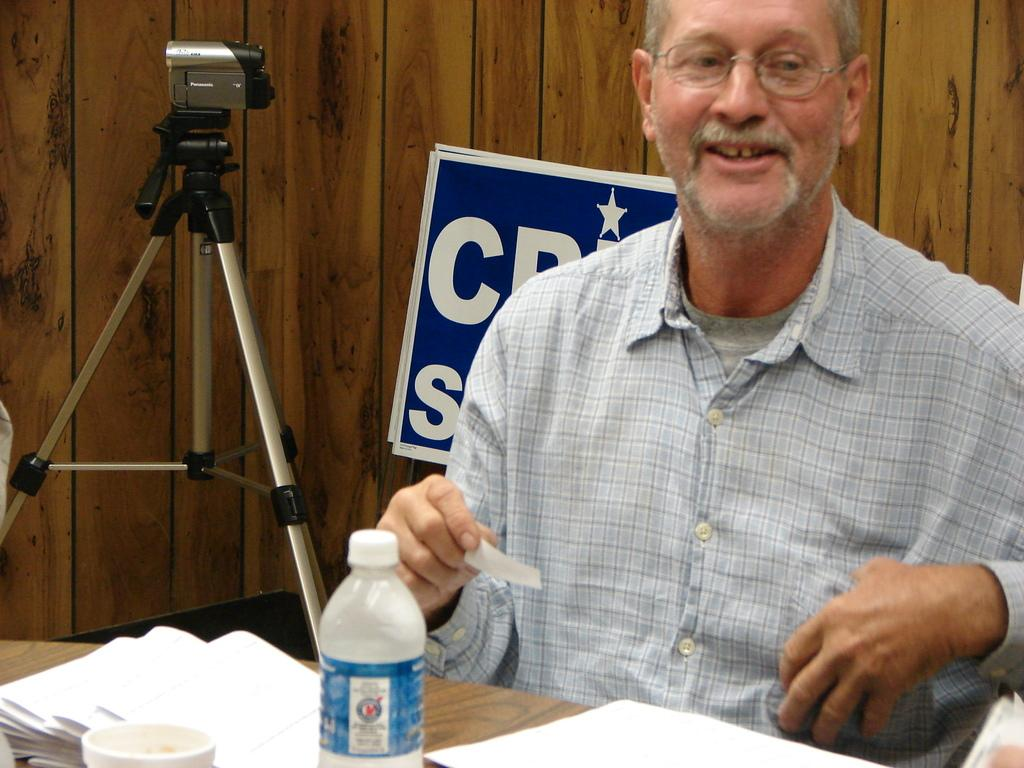What is the man in the image doing? The man is sitting on a chair. What object is on the chair with the man? There is a water bottle on the chair. What type of throne is the man sitting on in the image? The image does not depict a throne; it shows a man sitting on a regular chair. Can you see any pickles in the image? There are no pickles present in the image. 